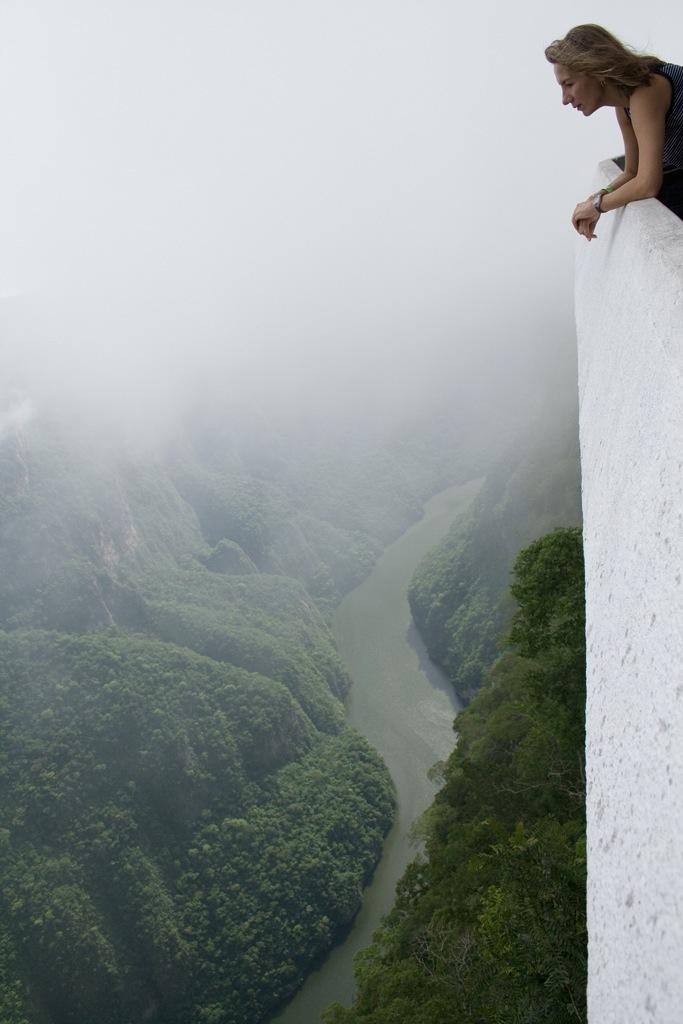What is the woman's position in relation to the wall in the image? The woman is standing behind a wall in the image. What geographical features can be seen at the bottom of the image? There are mountains at the bottom of the image. What type of vegetation is present in the image? There are trees in the image. What natural element is visible in the image? There is water visible in the image. What atmospheric condition is present at the top of the image? There is fog at the top of the image. What type of nerve can be seen in the image? There is no nerve present in the image. What kind of jewel is being worn by the woman in the image? There is no jewel visible on the woman in the image. 